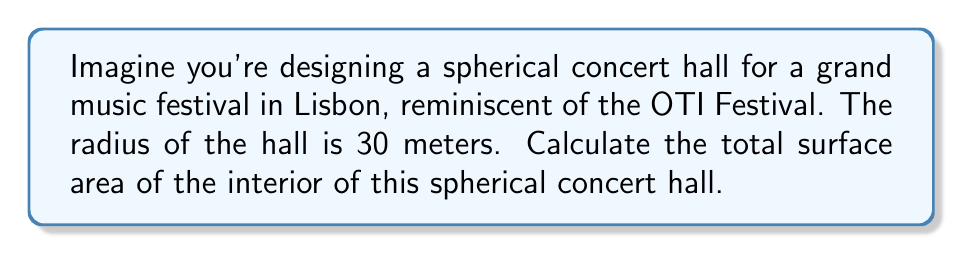Provide a solution to this math problem. To solve this problem, we need to use the formula for the surface area of a sphere. The surface area of a sphere is given by the equation:

$$A = 4\pi r^2$$

Where:
$A$ is the surface area
$\pi$ is the mathematical constant pi (approximately 3.14159)
$r$ is the radius of the sphere

Given:
- The radius of the spherical concert hall is 30 meters.

Let's substitute this value into our formula:

$$\begin{align}
A &= 4\pi r^2 \\
&= 4\pi (30\text{ m})^2 \\
&= 4\pi (900\text{ m}^2) \\
&= 3600\pi\text{ m}^2
\end{align}$$

Now, let's calculate this value:

$$3600\pi\text{ m}^2 \approx 11,309.73\text{ m}^2$$

Rounding to two decimal places, we get 11,309.73 square meters.

This represents the total interior surface area of the spherical concert hall, including the floor, walls, and ceiling, all of which form a continuous spherical surface.
Answer: The surface area of the spherical concert hall is approximately 11,309.73 square meters. 